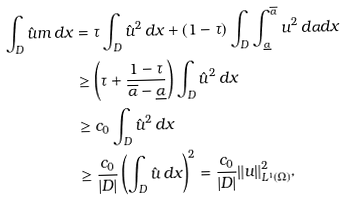Convert formula to latex. <formula><loc_0><loc_0><loc_500><loc_500>\int _ { D } \hat { u } m \, d x & = \tau \int _ { D } \hat { u } ^ { 2 } \, d x + ( 1 - \tau ) \int _ { D } \int _ { \underline { \alpha } } ^ { \overline { \alpha } } u ^ { 2 } \, d \alpha d x \\ & \geq \left ( \tau + \frac { 1 - \tau } { \overline { \alpha } - \underline { \alpha } } \right ) \int _ { D } \hat { u } ^ { 2 } \, d x \\ & \geq c _ { 0 } \int _ { D } \hat { u } ^ { 2 } \, d x \\ & \geq \frac { c _ { 0 } } { | D | } \left ( \int _ { D } \hat { u } \, d x \right ) ^ { 2 } = \frac { c _ { 0 } } { | D | } \| u \| _ { L ^ { 1 } ( { \Omega } ) } ^ { 2 } ,</formula> 